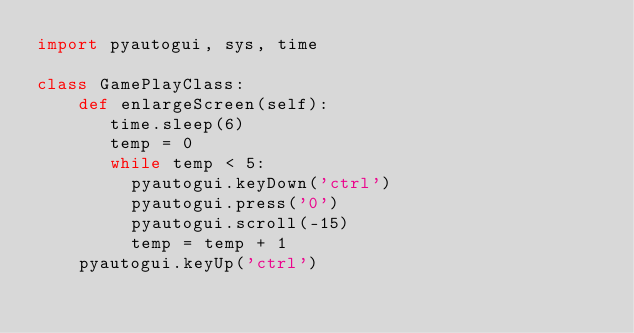Convert code to text. <code><loc_0><loc_0><loc_500><loc_500><_Python_>import pyautogui, sys, time

class GamePlayClass:
    def enlargeScreen(self):
       time.sleep(6)
       temp = 0
       while temp < 5:
         pyautogui.keyDown('ctrl')
         pyautogui.press('0')
         pyautogui.scroll(-15)
         temp = temp + 1
    pyautogui.keyUp('ctrl')</code> 